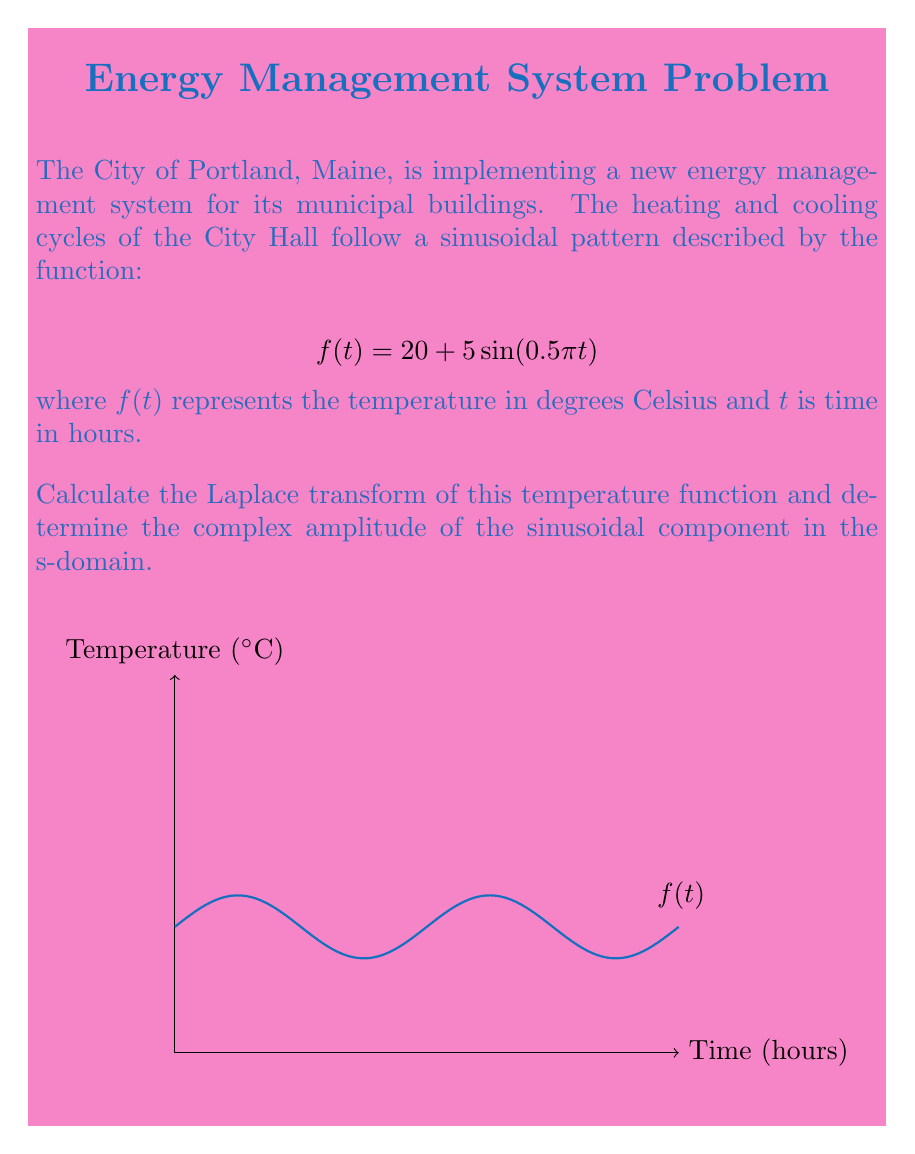Help me with this question. Let's approach this step-by-step:

1) The Laplace transform of a sinusoidal function is given by:

   $$\mathcal{L}\{A\sin(\omega t)\} = \frac{A\omega}{s^2 + \omega^2}$$

2) In our case, $A = 5$ and $\omega = 0.5\pi$. We also have a constant term of 20.

3) The Laplace transform of a constant $k$ is $\frac{k}{s}$.

4) Therefore, we can write the Laplace transform of our function as:

   $$F(s) = \mathcal{L}\{20 + 5\sin(0.5\pi t)\} = \frac{20}{s} + \frac{5(0.5\pi)}{s^2 + (0.5\pi)^2}$$

5) Simplifying:

   $$F(s) = \frac{20}{s} + \frac{2.5\pi}{s^2 + 0.25\pi^2}$$

6) The complex amplitude of the sinusoidal component in the s-domain is the coefficient of the second term:

   $$2.5\pi \approx 7.85$$
Answer: $F(s) = \frac{20}{s} + \frac{2.5\pi}{s^2 + 0.25\pi^2}$; Complex amplitude ≈ 7.85 